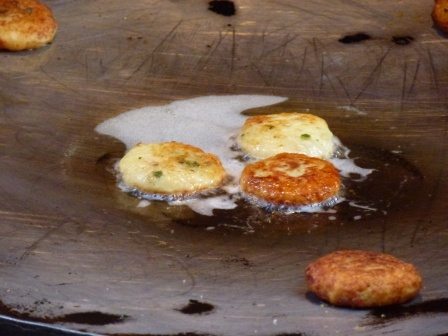What is the most appetizing feature of this image? The most appetizing feature is the golden-brown color of the pancakes, indicating they are perfectly cooked to offer a delightful crispy texture with a tender inside. The subtle green from the chives promises a hint of fresh, savory flavor combined with the richness of the batter. 